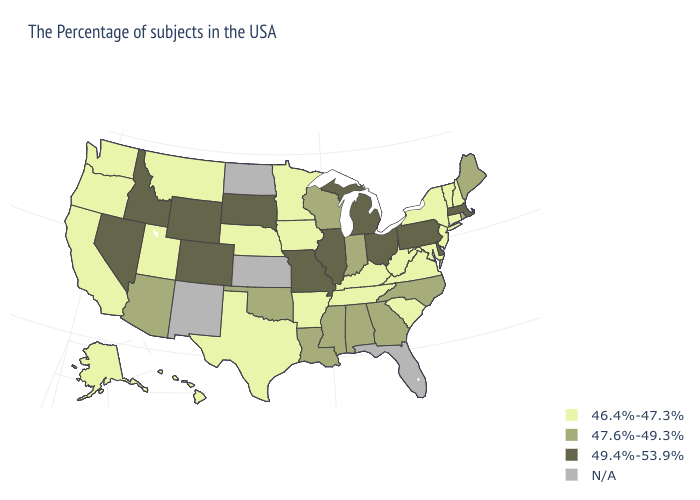Which states have the highest value in the USA?
Answer briefly. Massachusetts, Delaware, Pennsylvania, Ohio, Michigan, Illinois, Missouri, South Dakota, Wyoming, Colorado, Idaho, Nevada. Is the legend a continuous bar?
Concise answer only. No. Does Minnesota have the highest value in the MidWest?
Quick response, please. No. What is the value of North Carolina?
Be succinct. 47.6%-49.3%. What is the lowest value in states that border New York?
Write a very short answer. 46.4%-47.3%. What is the lowest value in the West?
Be succinct. 46.4%-47.3%. What is the value of New Jersey?
Write a very short answer. 46.4%-47.3%. What is the value of Alabama?
Quick response, please. 47.6%-49.3%. What is the value of Kansas?
Write a very short answer. N/A. Name the states that have a value in the range 46.4%-47.3%?
Be succinct. New Hampshire, Vermont, Connecticut, New York, New Jersey, Maryland, Virginia, South Carolina, West Virginia, Kentucky, Tennessee, Arkansas, Minnesota, Iowa, Nebraska, Texas, Utah, Montana, California, Washington, Oregon, Alaska, Hawaii. How many symbols are there in the legend?
Give a very brief answer. 4. What is the value of Pennsylvania?
Short answer required. 49.4%-53.9%. Which states have the highest value in the USA?
Quick response, please. Massachusetts, Delaware, Pennsylvania, Ohio, Michigan, Illinois, Missouri, South Dakota, Wyoming, Colorado, Idaho, Nevada. 